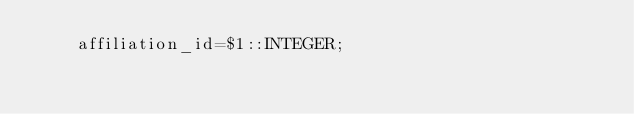<code> <loc_0><loc_0><loc_500><loc_500><_SQL_>    affiliation_id=$1::INTEGER;
</code> 